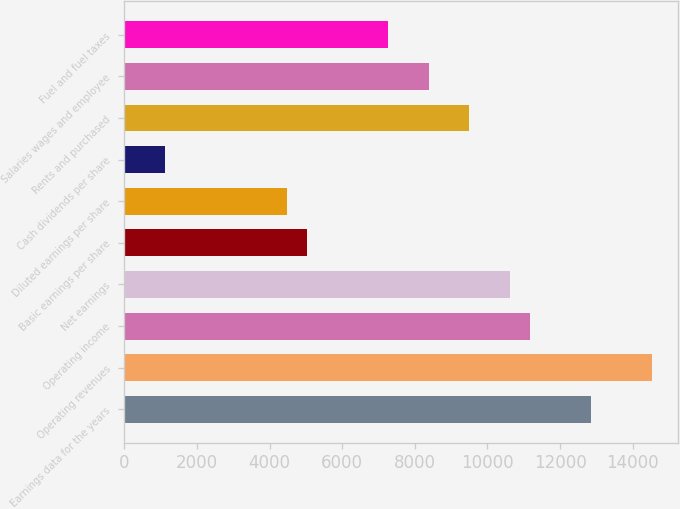Convert chart to OTSL. <chart><loc_0><loc_0><loc_500><loc_500><bar_chart><fcel>Earnings data for the years<fcel>Operating revenues<fcel>Operating income<fcel>Net earnings<fcel>Basic earnings per share<fcel>Diluted earnings per share<fcel>Cash dividends per share<fcel>Rents and purchased<fcel>Salaries wages and employee<fcel>Fuel and fuel taxes<nl><fcel>12845.1<fcel>14520.5<fcel>11169.7<fcel>10611.2<fcel>5026.53<fcel>4468.06<fcel>1117.24<fcel>9494.29<fcel>8377.35<fcel>7260.41<nl></chart> 